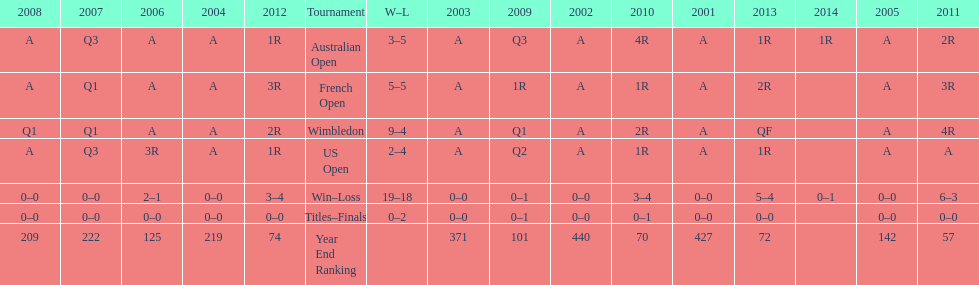In what year was the best year end ranking achieved? 2011. 